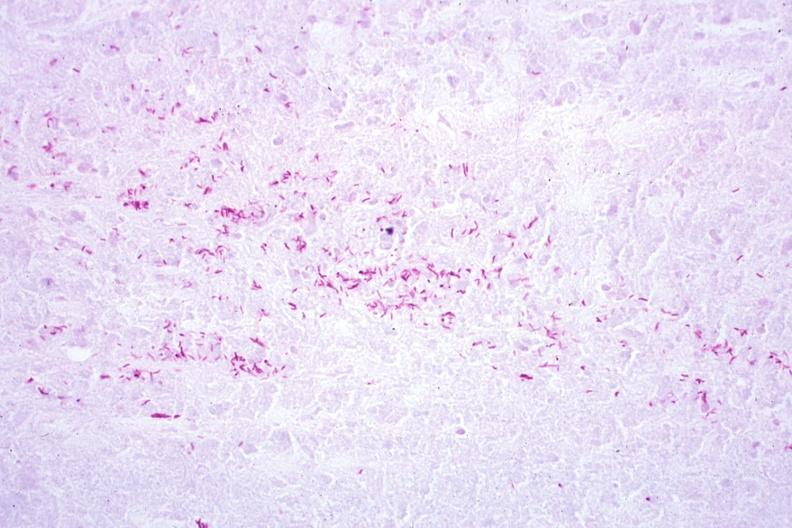does this image show acid fast stain a zillion organisms?
Answer the question using a single word or phrase. Yes 